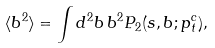<formula> <loc_0><loc_0><loc_500><loc_500>\langle b ^ { 2 } \rangle = \int d ^ { 2 } { b } \, b ^ { 2 } P _ { 2 } ( s , b ; p _ { t } ^ { c } ) ,</formula> 